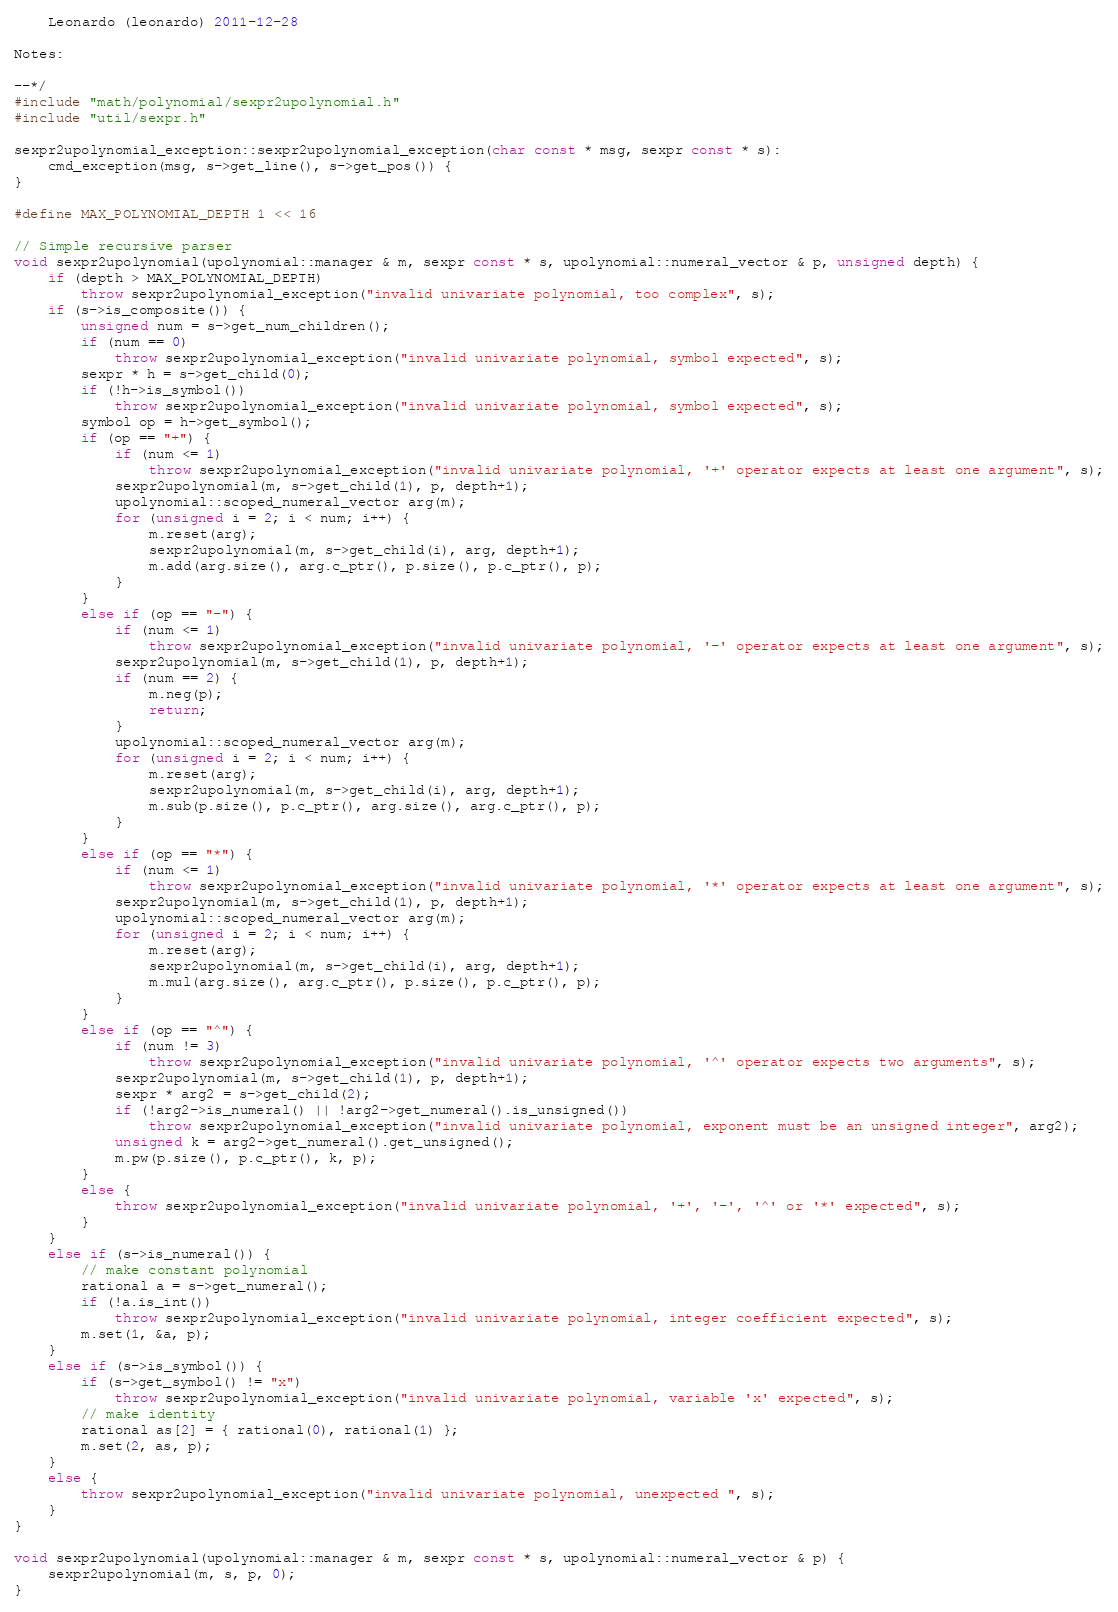<code> <loc_0><loc_0><loc_500><loc_500><_C++_>
    Leonardo (leonardo) 2011-12-28

Notes:

--*/
#include "math/polynomial/sexpr2upolynomial.h"
#include "util/sexpr.h"

sexpr2upolynomial_exception::sexpr2upolynomial_exception(char const * msg, sexpr const * s):
    cmd_exception(msg, s->get_line(), s->get_pos()) {
}

#define MAX_POLYNOMIAL_DEPTH 1 << 16

// Simple recursive parser
void sexpr2upolynomial(upolynomial::manager & m, sexpr const * s, upolynomial::numeral_vector & p, unsigned depth) {
    if (depth > MAX_POLYNOMIAL_DEPTH)
        throw sexpr2upolynomial_exception("invalid univariate polynomial, too complex", s);
    if (s->is_composite()) {
        unsigned num = s->get_num_children();
        if (num == 0)
            throw sexpr2upolynomial_exception("invalid univariate polynomial, symbol expected", s);
        sexpr * h = s->get_child(0);
        if (!h->is_symbol())
            throw sexpr2upolynomial_exception("invalid univariate polynomial, symbol expected", s);
        symbol op = h->get_symbol();
        if (op == "+") {
            if (num <= 1)
                throw sexpr2upolynomial_exception("invalid univariate polynomial, '+' operator expects at least one argument", s);
            sexpr2upolynomial(m, s->get_child(1), p, depth+1);
            upolynomial::scoped_numeral_vector arg(m);
            for (unsigned i = 2; i < num; i++) {
                m.reset(arg);
                sexpr2upolynomial(m, s->get_child(i), arg, depth+1);
                m.add(arg.size(), arg.c_ptr(), p.size(), p.c_ptr(), p);
            }
        }
        else if (op == "-") {
            if (num <= 1)
                throw sexpr2upolynomial_exception("invalid univariate polynomial, '-' operator expects at least one argument", s);
            sexpr2upolynomial(m, s->get_child(1), p, depth+1);
            if (num == 2) {
                m.neg(p);
                return;
            }
            upolynomial::scoped_numeral_vector arg(m);
            for (unsigned i = 2; i < num; i++) {
                m.reset(arg);
                sexpr2upolynomial(m, s->get_child(i), arg, depth+1);
                m.sub(p.size(), p.c_ptr(), arg.size(), arg.c_ptr(), p);
            }
        }
        else if (op == "*") {
            if (num <= 1)
                throw sexpr2upolynomial_exception("invalid univariate polynomial, '*' operator expects at least one argument", s);
            sexpr2upolynomial(m, s->get_child(1), p, depth+1);
            upolynomial::scoped_numeral_vector arg(m);
            for (unsigned i = 2; i < num; i++) {
                m.reset(arg);
                sexpr2upolynomial(m, s->get_child(i), arg, depth+1);
                m.mul(arg.size(), arg.c_ptr(), p.size(), p.c_ptr(), p);
            }
        }
        else if (op == "^") {
            if (num != 3)
                throw sexpr2upolynomial_exception("invalid univariate polynomial, '^' operator expects two arguments", s);
            sexpr2upolynomial(m, s->get_child(1), p, depth+1);
            sexpr * arg2 = s->get_child(2);
            if (!arg2->is_numeral() || !arg2->get_numeral().is_unsigned())
                throw sexpr2upolynomial_exception("invalid univariate polynomial, exponent must be an unsigned integer", arg2);
            unsigned k = arg2->get_numeral().get_unsigned();
            m.pw(p.size(), p.c_ptr(), k, p);
        }
        else {
            throw sexpr2upolynomial_exception("invalid univariate polynomial, '+', '-', '^' or '*' expected", s);
        }
    }
    else if (s->is_numeral()) {
        // make constant polynomial
        rational a = s->get_numeral();
        if (!a.is_int())
            throw sexpr2upolynomial_exception("invalid univariate polynomial, integer coefficient expected", s);
        m.set(1, &a, p);
    }
    else if (s->is_symbol()) {
        if (s->get_symbol() != "x") 
            throw sexpr2upolynomial_exception("invalid univariate polynomial, variable 'x' expected", s);
        // make identity
        rational as[2] = { rational(0), rational(1) };
        m.set(2, as, p);
    }
    else {
        throw sexpr2upolynomial_exception("invalid univariate polynomial, unexpected ", s);
    }
} 

void sexpr2upolynomial(upolynomial::manager & m, sexpr const * s, upolynomial::numeral_vector & p) {
    sexpr2upolynomial(m, s, p, 0);
}
</code> 